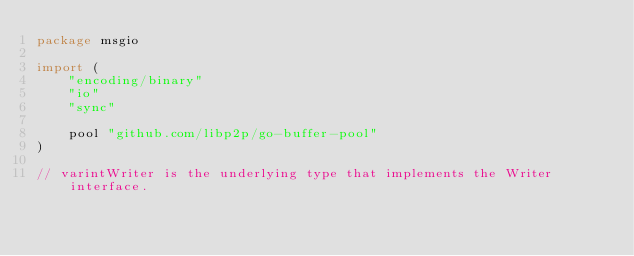<code> <loc_0><loc_0><loc_500><loc_500><_Go_>package msgio

import (
	"encoding/binary"
	"io"
	"sync"

	pool "github.com/libp2p/go-buffer-pool"
)

// varintWriter is the underlying type that implements the Writer interface.</code> 